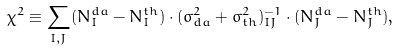Convert formula to latex. <formula><loc_0><loc_0><loc_500><loc_500>\chi ^ { 2 } \equiv \sum _ { I , J } ( N _ { I } ^ { d a } - N _ { I } ^ { t h } ) \cdot ( \sigma _ { d a } ^ { 2 } + \sigma _ { t h } ^ { 2 } ) _ { I J } ^ { - 1 } \cdot ( N _ { J } ^ { d a } - N _ { J } ^ { t h } ) ,</formula> 